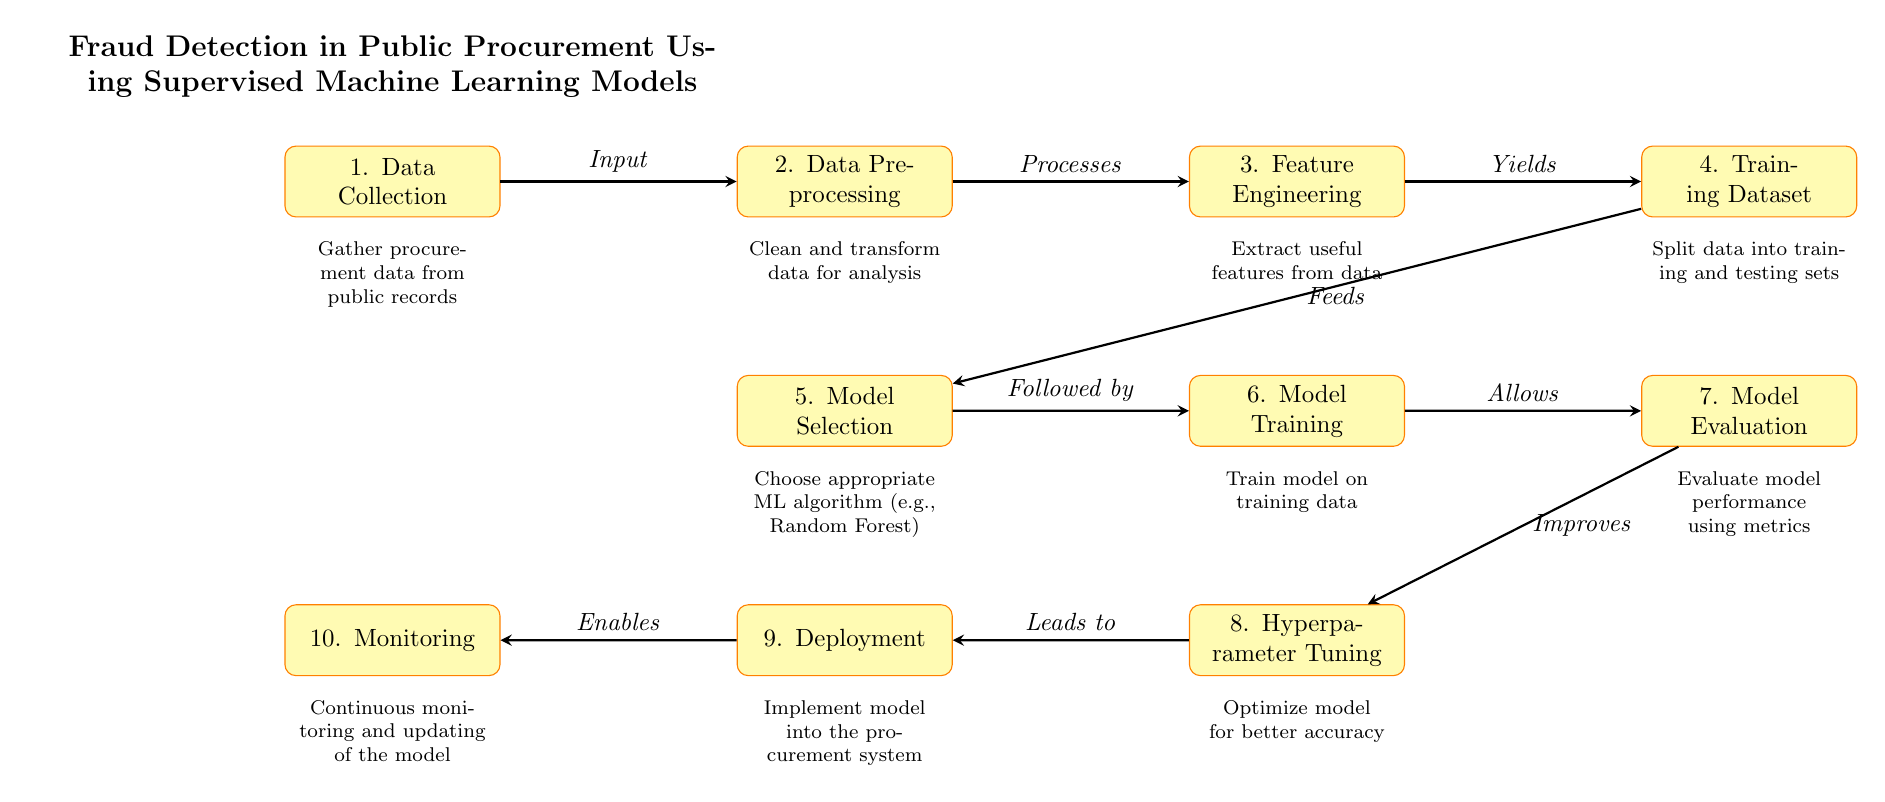What is the first step in the process? The diagram lists the first step as "Data Collection," which is placed at the top.
Answer: Data Collection How many processes are involved in the diagram? Counting the rectangular nodes in the diagram, there are a total of ten distinct processes listed.
Answer: Ten What does the output of step three yield? The diagram specifies that step three, "Feature Engineering," yields a "Training Dataset," as indicated directly from the arrow leading to step four.
Answer: Training Dataset What follows the "Model Selection" step? The arrow leading from "Model Selection" points to "Model Training," indicating that it follows directly in the process flow.
Answer: Model Training Which model evaluation metric is suggested after training? At step seven, the diagram mentions that "Evaluate model performance using metrics" is part of the process that takes place after model training.
Answer: Metrics What is the ultimate role of the last step in the process? The last step "Monitoring" is indicated to be enabled by the "Deployment" step, suggesting that it serves to continuously check the system's performance post-deployment.
Answer: Continuous monitoring Which algorithm type is indicated for model selection? The diagram implies the need to choose an appropriate machine learning algorithm, with "Random Forest" mentioned as an example during the "Model Selection" phase.
Answer: Random Forest What leads to the Hyperparameter Tuning step? The diagram shows that after the model evaluation, it improves the overall process, leading to "Hyperparameter Tuning," making it a subsequent step in the workflow.
Answer: Model Evaluation What do you gather in the data collection phase? The data collection phase involves gathering procurement data from public records, as specified in the descriptive part of the diagram for step one.
Answer: Procurement data from public records 